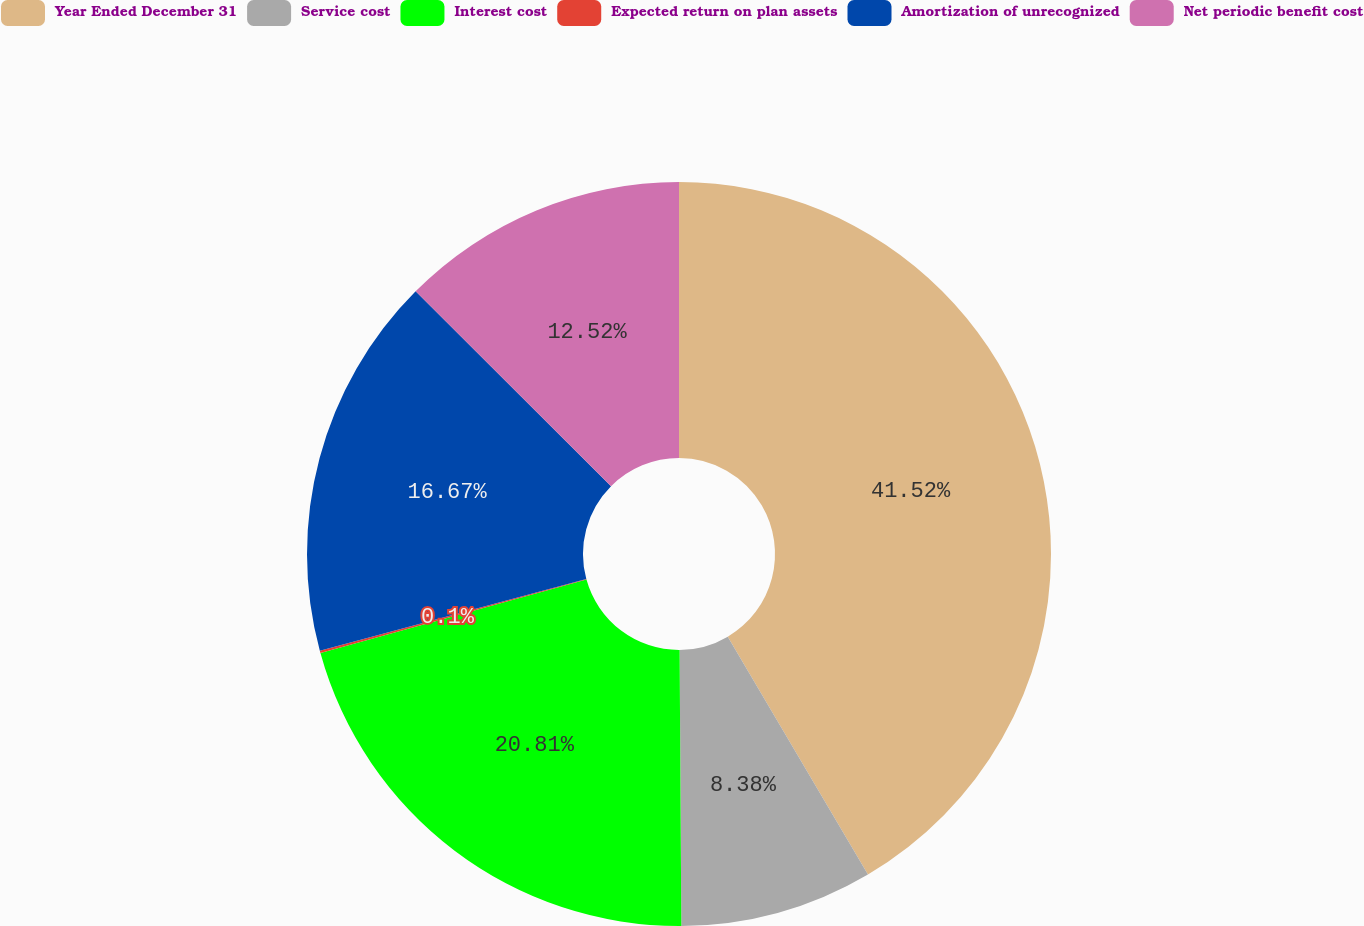<chart> <loc_0><loc_0><loc_500><loc_500><pie_chart><fcel>Year Ended December 31<fcel>Service cost<fcel>Interest cost<fcel>Expected return on plan assets<fcel>Amortization of unrecognized<fcel>Net periodic benefit cost<nl><fcel>41.52%<fcel>8.38%<fcel>20.81%<fcel>0.1%<fcel>16.67%<fcel>12.52%<nl></chart> 